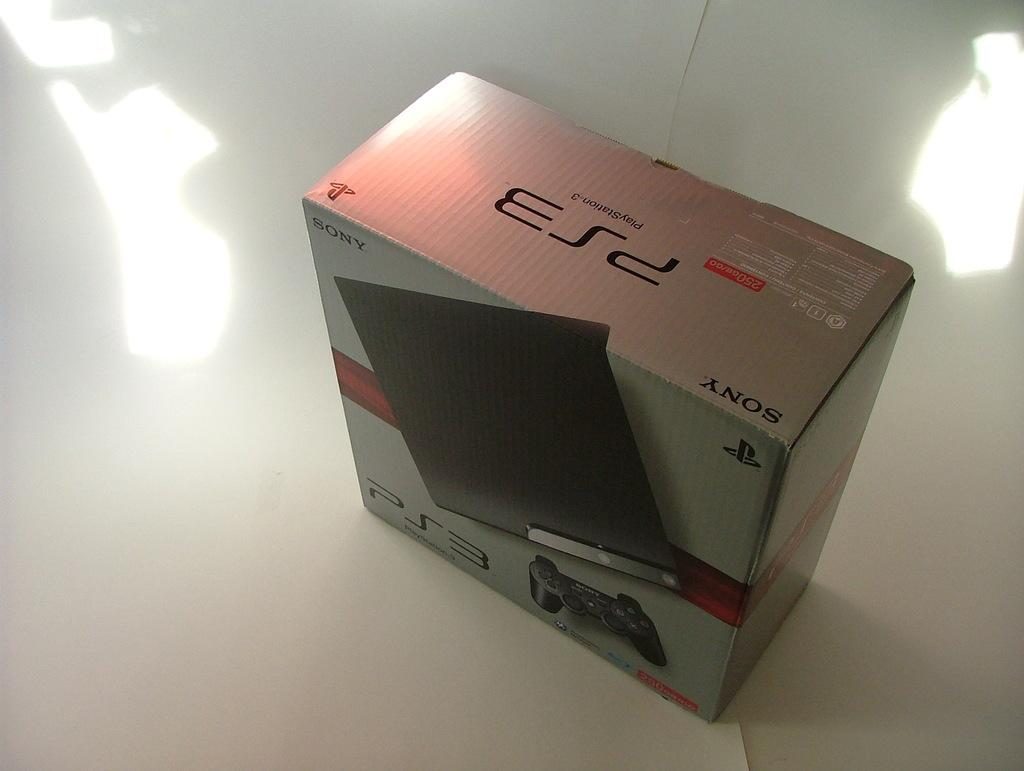<image>
Share a concise interpretation of the image provided. a PS3 in the box on a white surface 